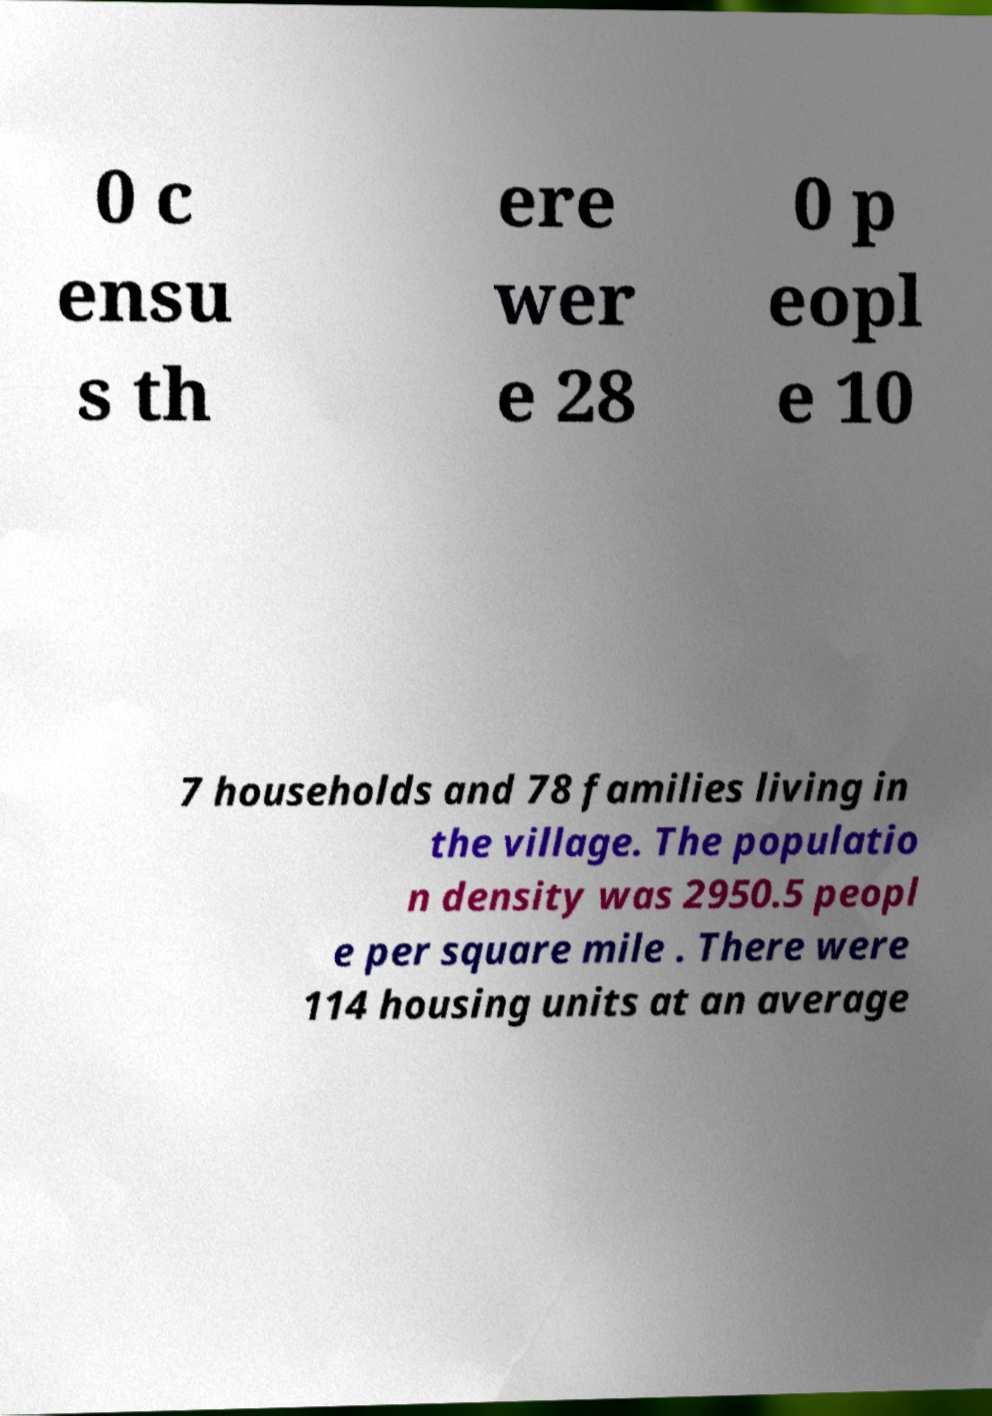Could you assist in decoding the text presented in this image and type it out clearly? 0 c ensu s th ere wer e 28 0 p eopl e 10 7 households and 78 families living in the village. The populatio n density was 2950.5 peopl e per square mile . There were 114 housing units at an average 